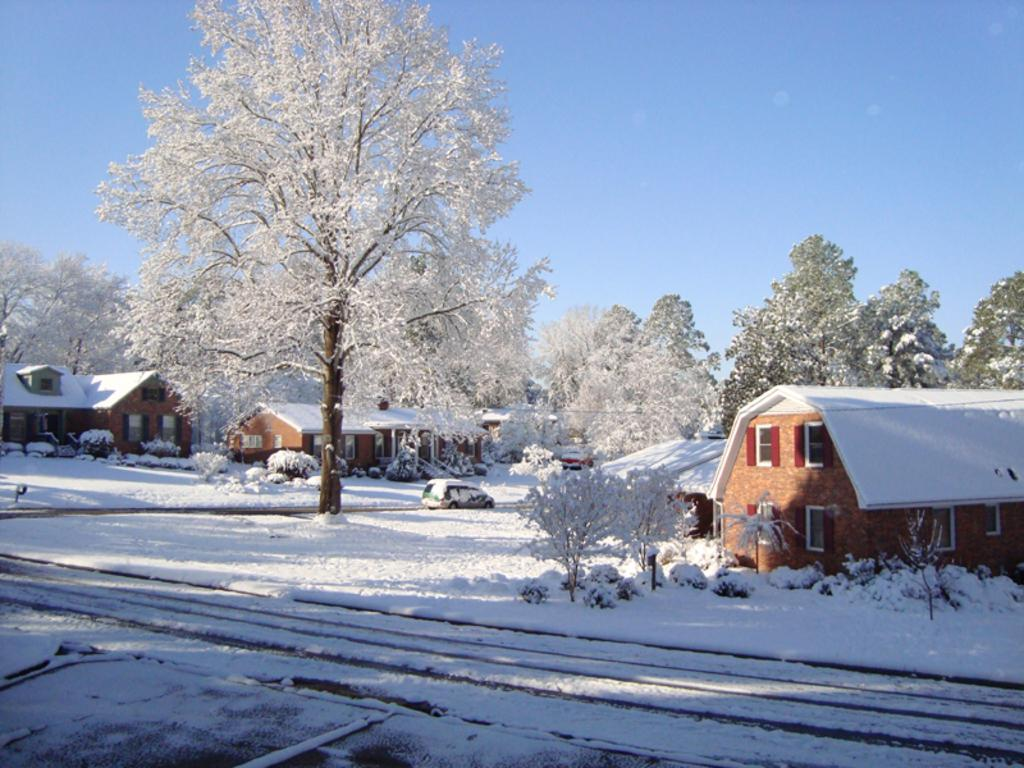What type of weather is depicted in the image? There is snow in the image, indicating a snowy or wintry weather. What celestial bodies can be seen in the image? There are planets visible in the image. What type of structures are present in the image? There are houses in the image. What mode of transportation can be seen in the image? There is a car on the road in the image. What type of vegetation is visible in the background of the image? Trees are present in the background of the image. What part of the natural environment is visible in the image? The sky is visible in the background of the image. What type of salt is sprinkled on the design of the swing in the image? There is no salt, design, or swing present in the image. 